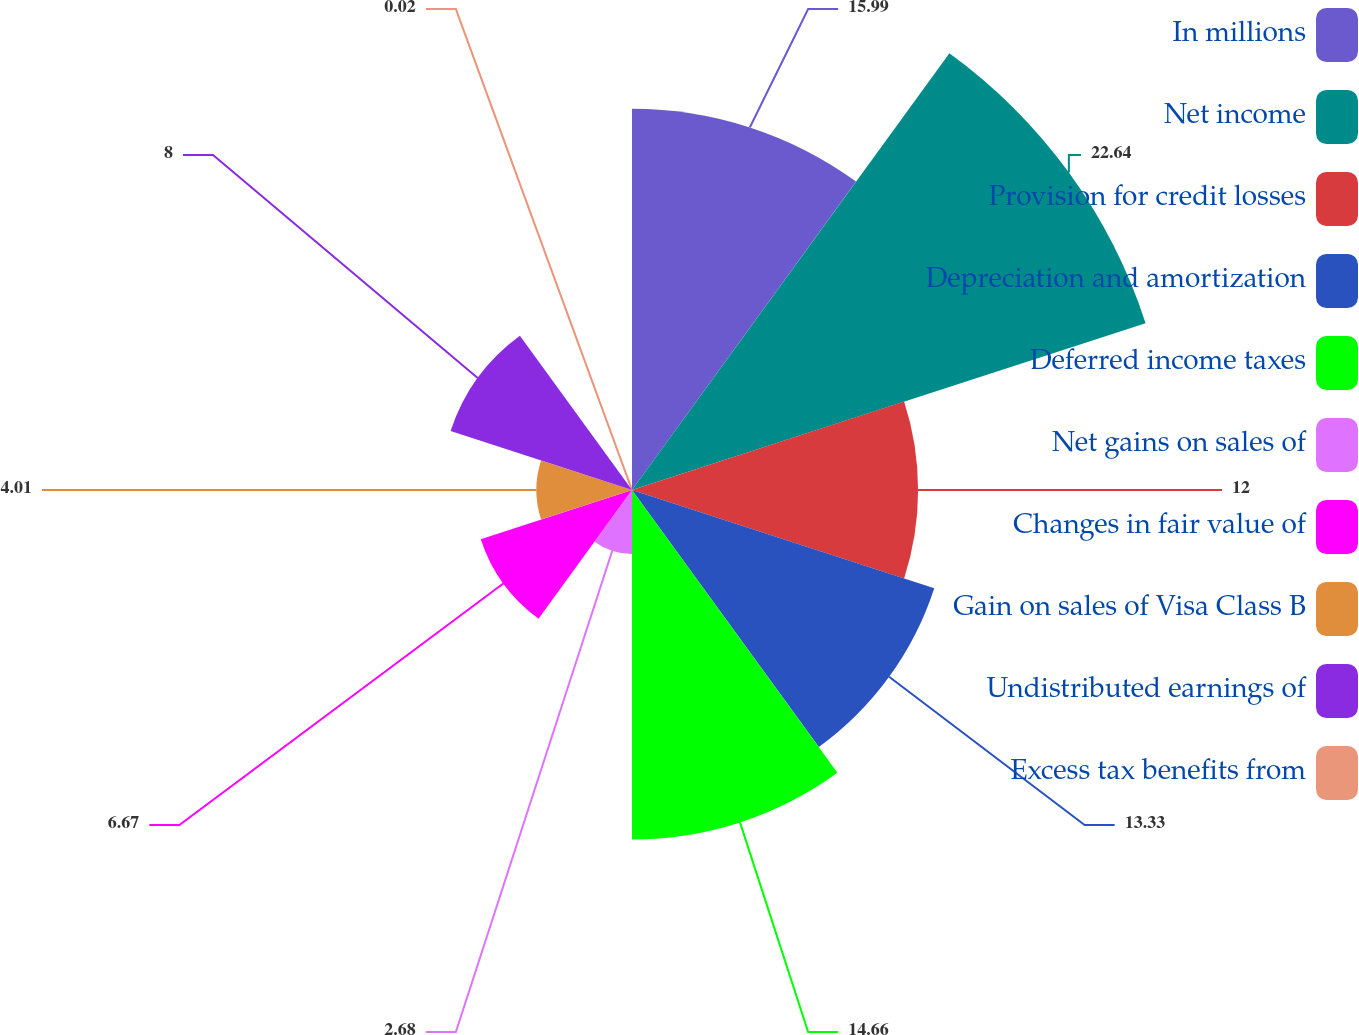<chart> <loc_0><loc_0><loc_500><loc_500><pie_chart><fcel>In millions<fcel>Net income<fcel>Provision for credit losses<fcel>Depreciation and amortization<fcel>Deferred income taxes<fcel>Net gains on sales of<fcel>Changes in fair value of<fcel>Gain on sales of Visa Class B<fcel>Undistributed earnings of<fcel>Excess tax benefits from<nl><fcel>15.99%<fcel>22.65%<fcel>12.0%<fcel>13.33%<fcel>14.66%<fcel>2.68%<fcel>6.67%<fcel>4.01%<fcel>8.0%<fcel>0.02%<nl></chart> 